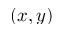Convert formula to latex. <formula><loc_0><loc_0><loc_500><loc_500>( x , y )</formula> 